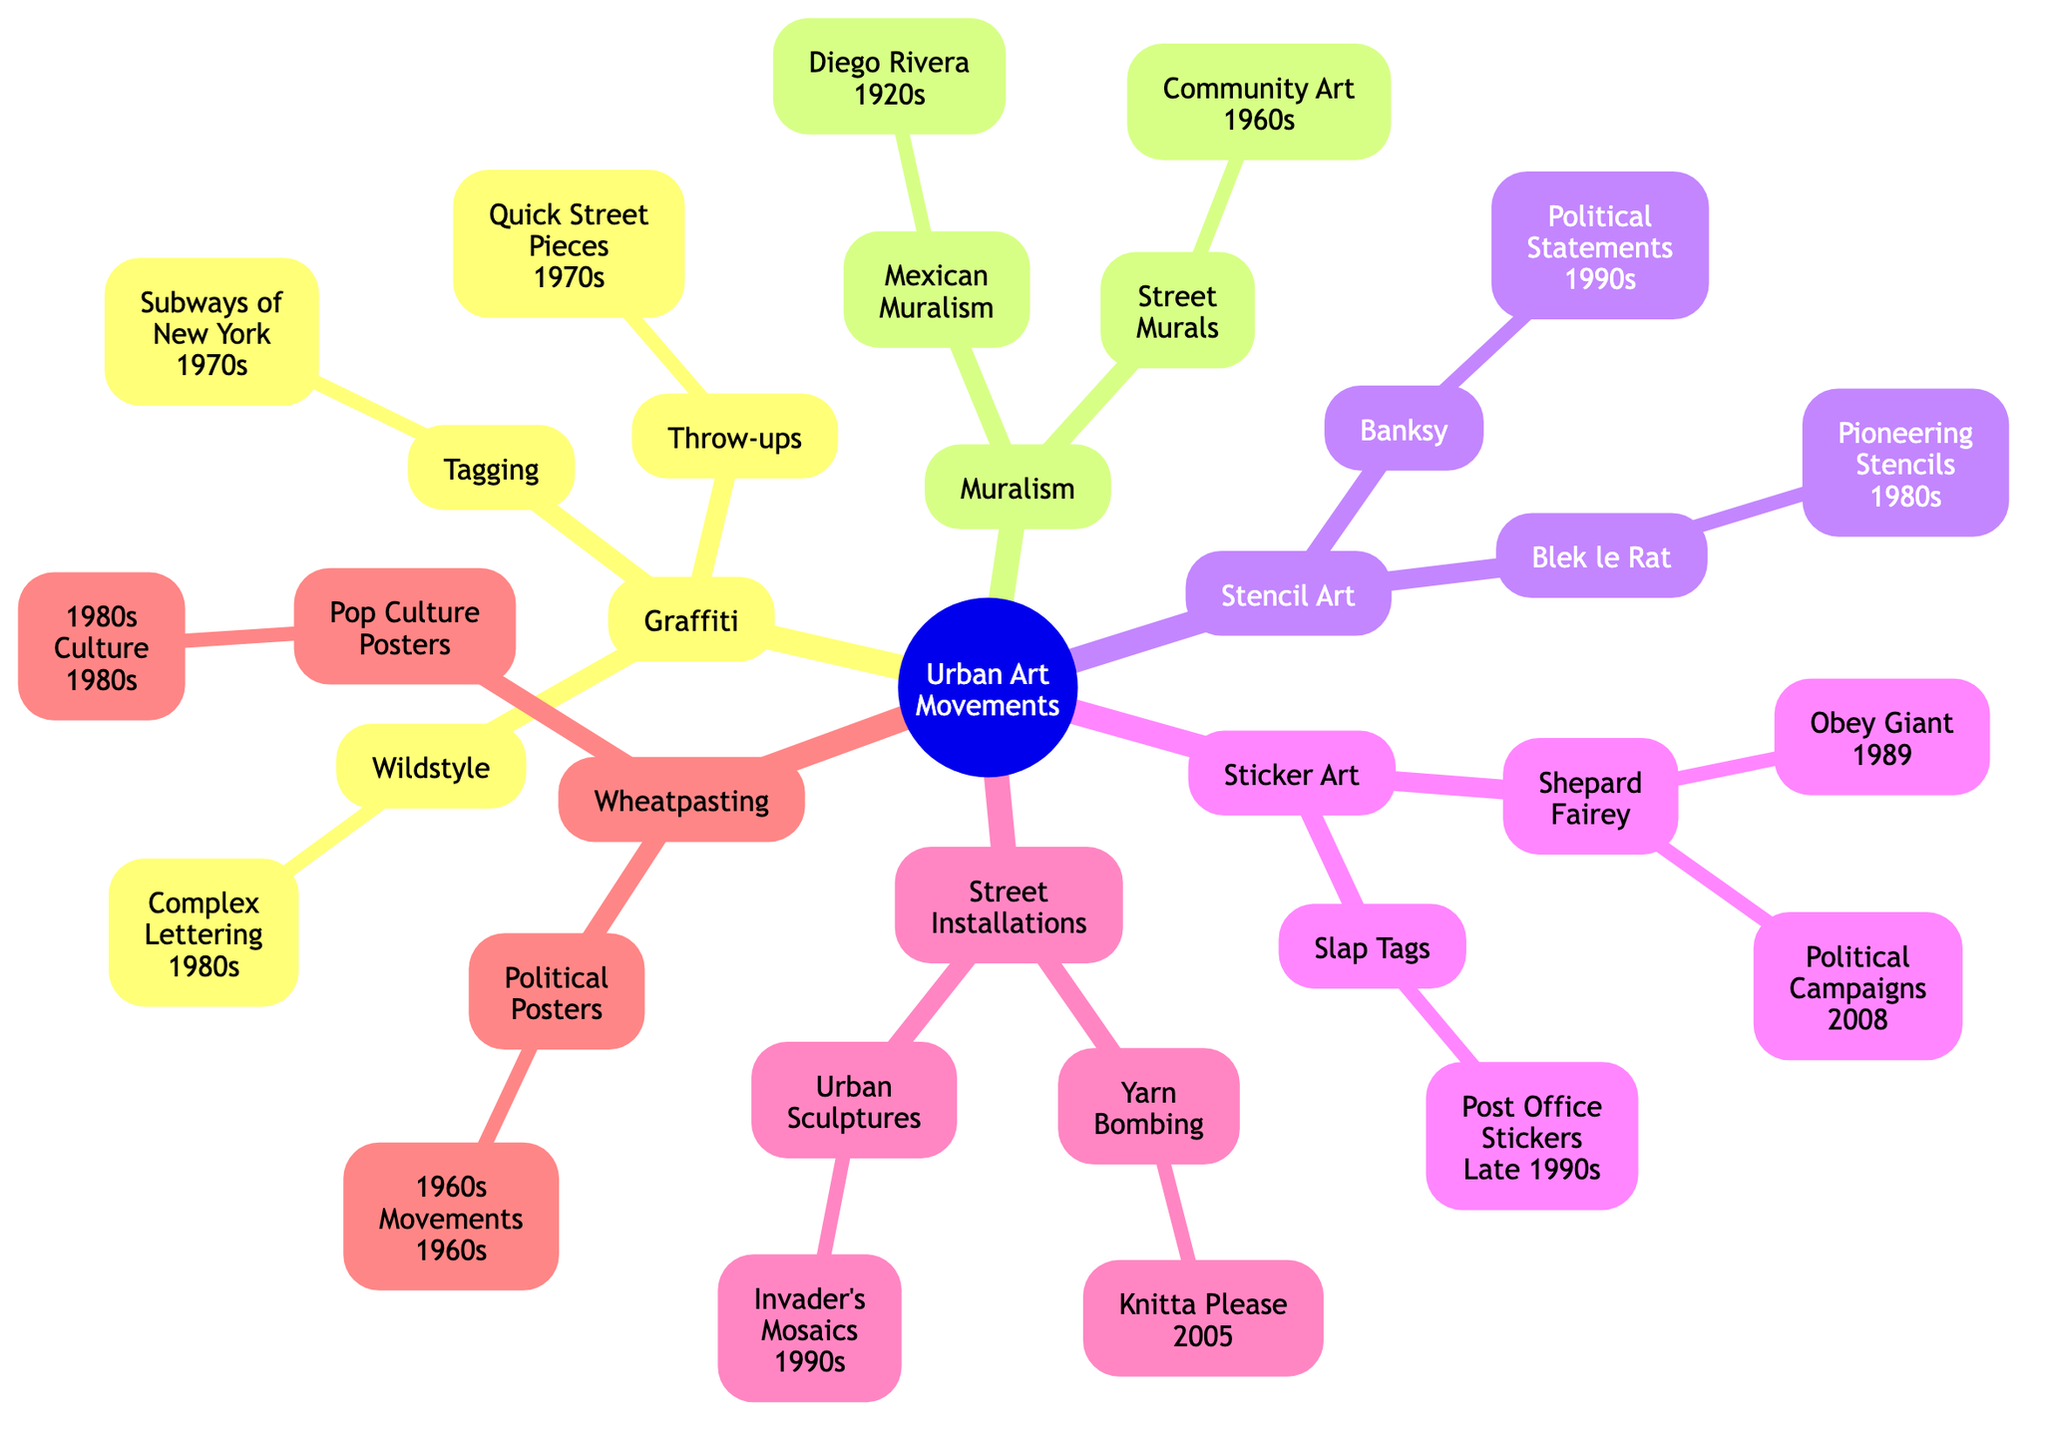What is the main node of the diagram? The diagram starts with a main node labeled "Urban Art Movements," which signifies the overarching theme of the family tree.
Answer: Urban Art Movements How many branches are under Graffiti? The Graffiti branch includes three sub-branches: Tagging, Throw-ups, and Wildstyle. By counting these, we find there are three sub-branches.
Answer: 3 In what decade did Wildstyle emerge? The sub-branch Wildstyle specifically mentions "Complex Lettering" and indicates it emerged in the "1980s." Therefore, the decade is clearly noted.
Answer: 1980s Who is associated with Mexican Muralism? The Mexican Muralism branch mentions Diego Rivera, identifying him as a key figure in this sub-branch, making him the person associated with it.
Answer: Diego Rivera What relationship does Stencil Art have with Banksy? The Stencil Art node contains a sub-branch with Banksy listed as a distinct artist known for his work in Stencil Art, highlighting an artistic relationship between the two.
Answer: Banksy What two categories are tagged under Sticker Art? The Sticker Art branch contains two sub-branches: Shepard Fairey and Slap Tags, categorizing the types of sticker art present in the diagram.
Answer: Shepard Fairey, Slap Tags Which urban art movement has the earliest year associated with it? The earliest year associated in the diagram is linked to Diego Rivera's Mexican Muralism in the "1920s." This makes it the first chronological mention in the context of urban art movements.
Answer: 1920s How many forms of art are listed under Street Installations? The Street Installations branch has two sub-branches: Yarn Bombing and Urban Sculptures. By counting these, we establish there are two distinct forms.
Answer: 2 What years are associated with Shepard Fairey’s work? Under the Shepard Fairey sub-branch, two specific works are mentioned: "Obey Giant" in 1989 and "Political Campaigns" in 2008. These years indicate the timeline of his contributions.
Answer: 1989, 2008 What does Knitta Please refer to? Knitta Please is mentioned under the Yarn Bombing sub-branch, indicating it specifically refers to an art piece or project related to yarn bombing that first appeared in 2005.
Answer: Knitta Please 